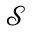Convert formula to latex. <formula><loc_0><loc_0><loc_500><loc_500>\mathcal { S }</formula> 